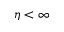<formula> <loc_0><loc_0><loc_500><loc_500>\eta < \infty</formula> 